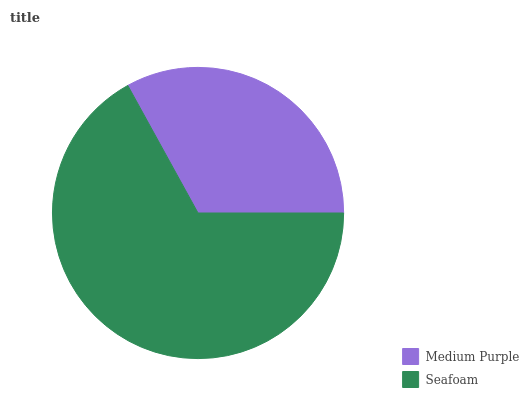Is Medium Purple the minimum?
Answer yes or no. Yes. Is Seafoam the maximum?
Answer yes or no. Yes. Is Seafoam the minimum?
Answer yes or no. No. Is Seafoam greater than Medium Purple?
Answer yes or no. Yes. Is Medium Purple less than Seafoam?
Answer yes or no. Yes. Is Medium Purple greater than Seafoam?
Answer yes or no. No. Is Seafoam less than Medium Purple?
Answer yes or no. No. Is Seafoam the high median?
Answer yes or no. Yes. Is Medium Purple the low median?
Answer yes or no. Yes. Is Medium Purple the high median?
Answer yes or no. No. Is Seafoam the low median?
Answer yes or no. No. 